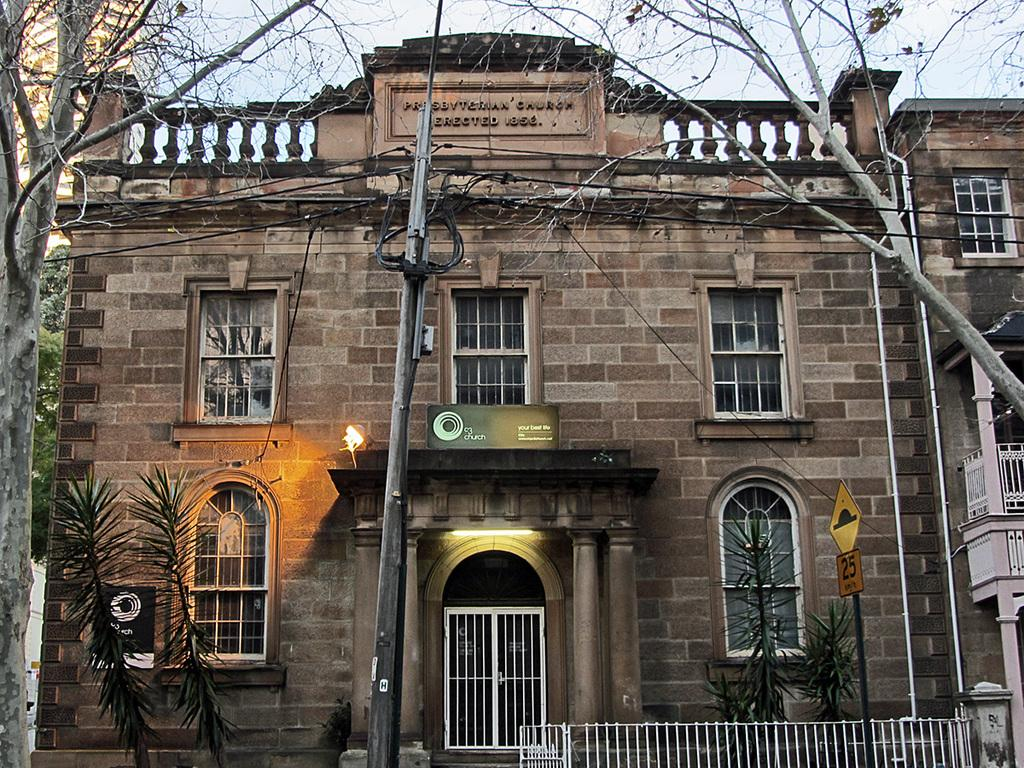What type of structure is visible in the image? There is a building in the image. What can be seen in front of the building? Trees, plants, a utility pole, a railing, and a pole with sign boards are visible in front of the building. What is visible in the background of the image? The sky is visible in the background of the image. What type of respect can be seen on the building in the image? There is no indication of respect on the building in the image; it is simply a structure with various objects in front of it. 